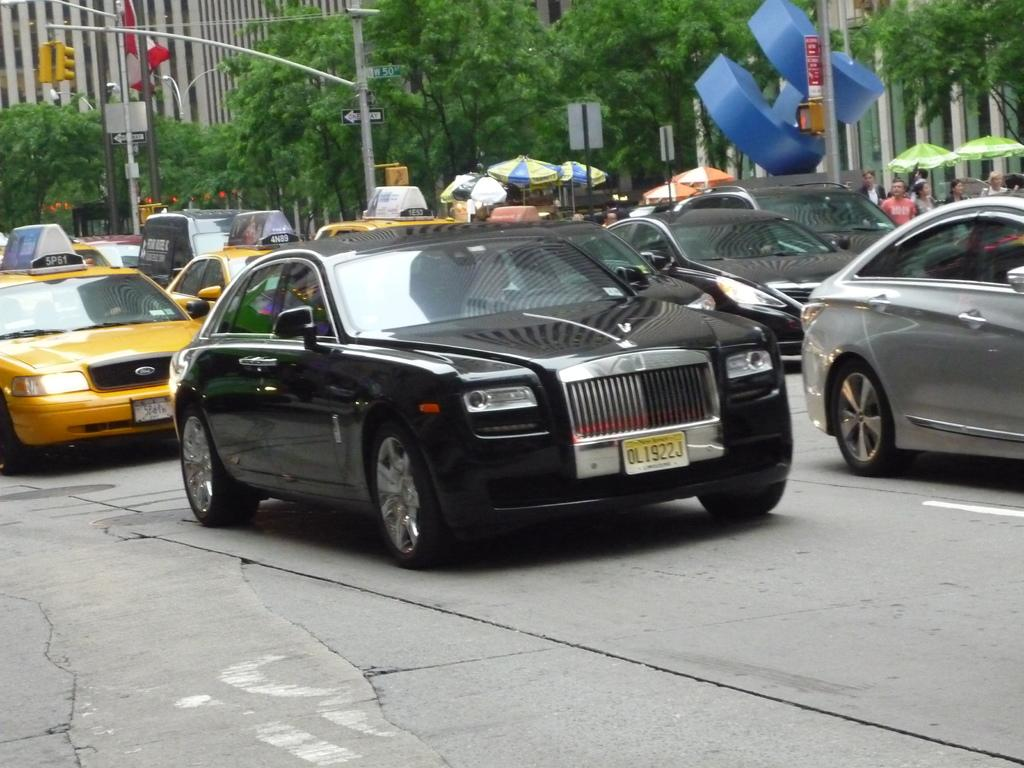<image>
Create a compact narrative representing the image presented. a license plate with OL written on it 